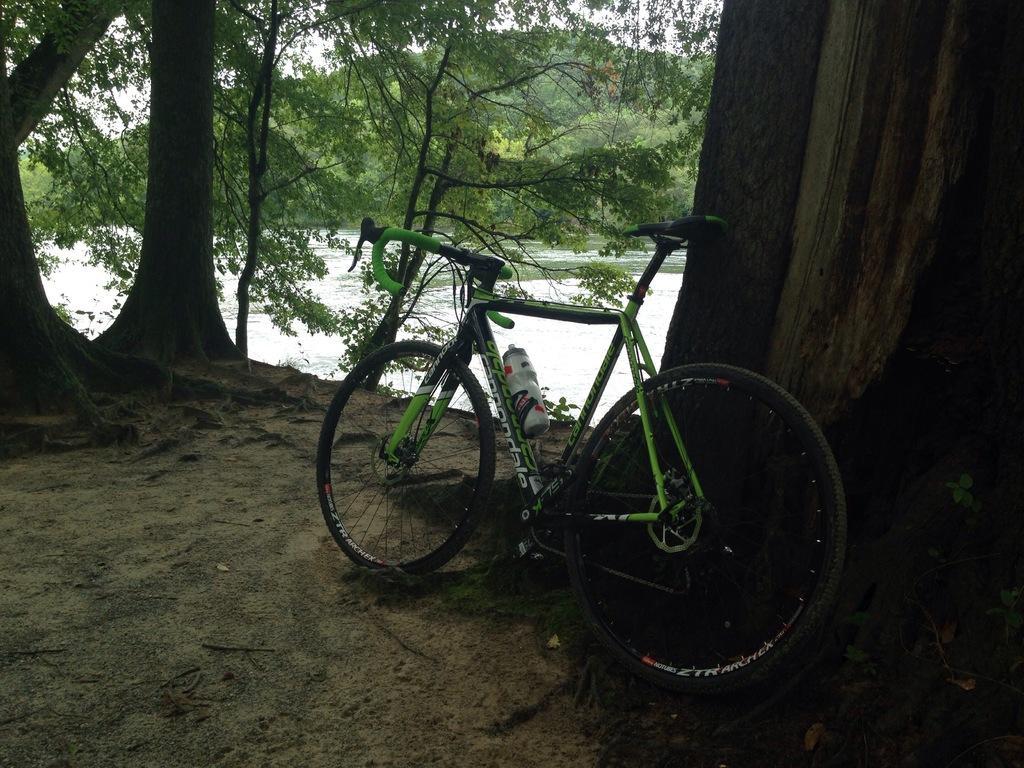How would you summarize this image in a sentence or two? In this image we can see there is a bicycle and a water bottle attached to it. In the background there is a river, trees and a sky. 